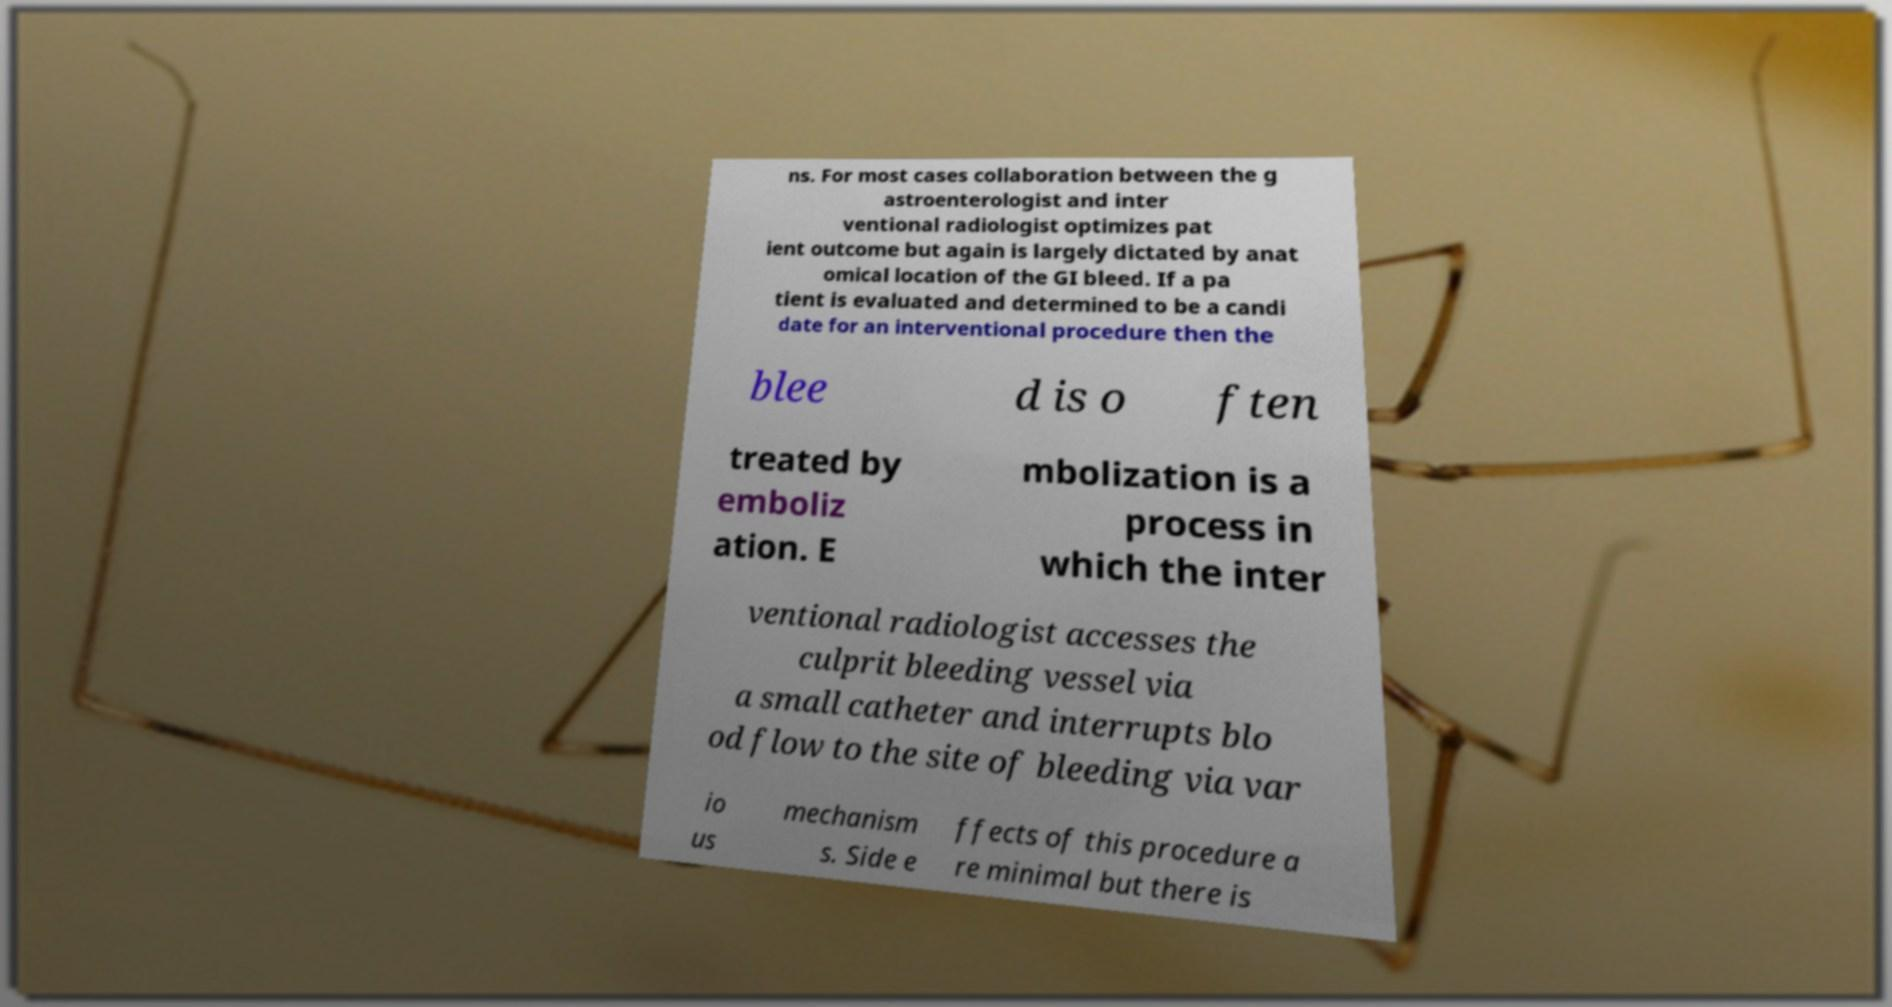Can you accurately transcribe the text from the provided image for me? ns. For most cases collaboration between the g astroenterologist and inter ventional radiologist optimizes pat ient outcome but again is largely dictated by anat omical location of the GI bleed. If a pa tient is evaluated and determined to be a candi date for an interventional procedure then the blee d is o ften treated by emboliz ation. E mbolization is a process in which the inter ventional radiologist accesses the culprit bleeding vessel via a small catheter and interrupts blo od flow to the site of bleeding via var io us mechanism s. Side e ffects of this procedure a re minimal but there is 